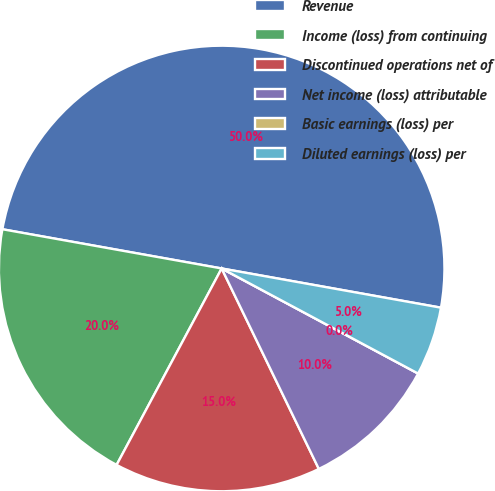<chart> <loc_0><loc_0><loc_500><loc_500><pie_chart><fcel>Revenue<fcel>Income (loss) from continuing<fcel>Discontinued operations net of<fcel>Net income (loss) attributable<fcel>Basic earnings (loss) per<fcel>Diluted earnings (loss) per<nl><fcel>50.0%<fcel>20.0%<fcel>15.0%<fcel>10.0%<fcel>0.0%<fcel>5.0%<nl></chart> 